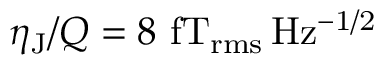<formula> <loc_0><loc_0><loc_500><loc_500>\eta _ { J } / Q = 8 f T _ { r m s } \, H z ^ { - 1 / 2 }</formula> 